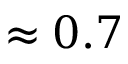<formula> <loc_0><loc_0><loc_500><loc_500>\approx 0 . 7</formula> 